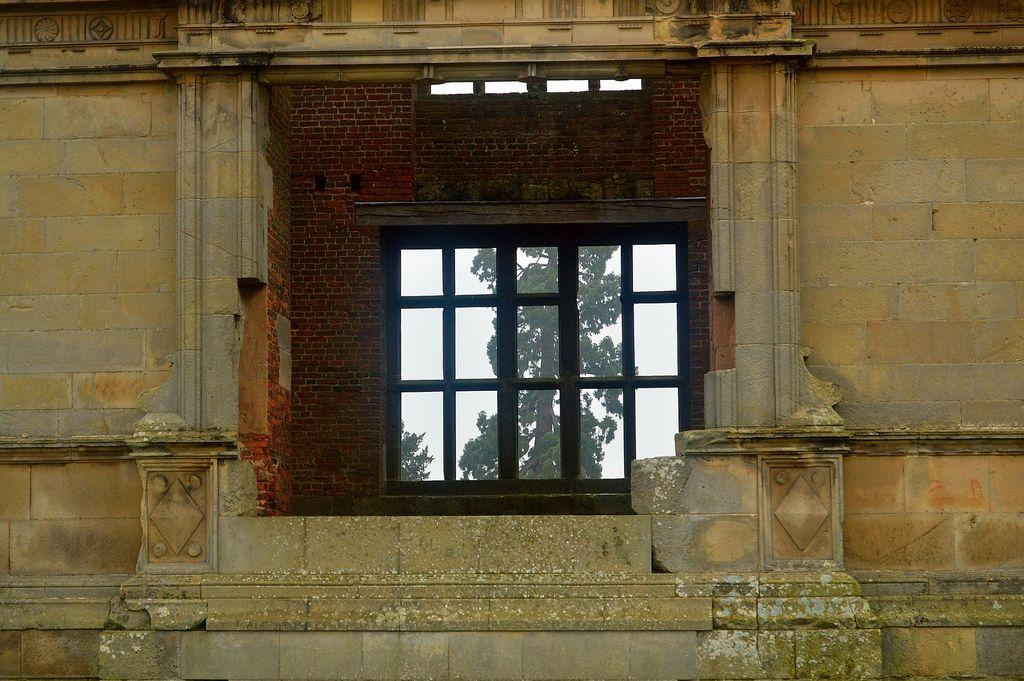What is located in the center of the image? There is a window in the center of the image. What type of structure can be seen in the image? There is a brick wall in the image. What is the closest object to the viewer in the image? There is a building in the foreground of the image. Can you see a snail crawling on the brick wall in the image? There is no snail present on the brick wall in the image. What type of tool is being used to dig in the image? There is no tool or digging activity depicted in the image. 